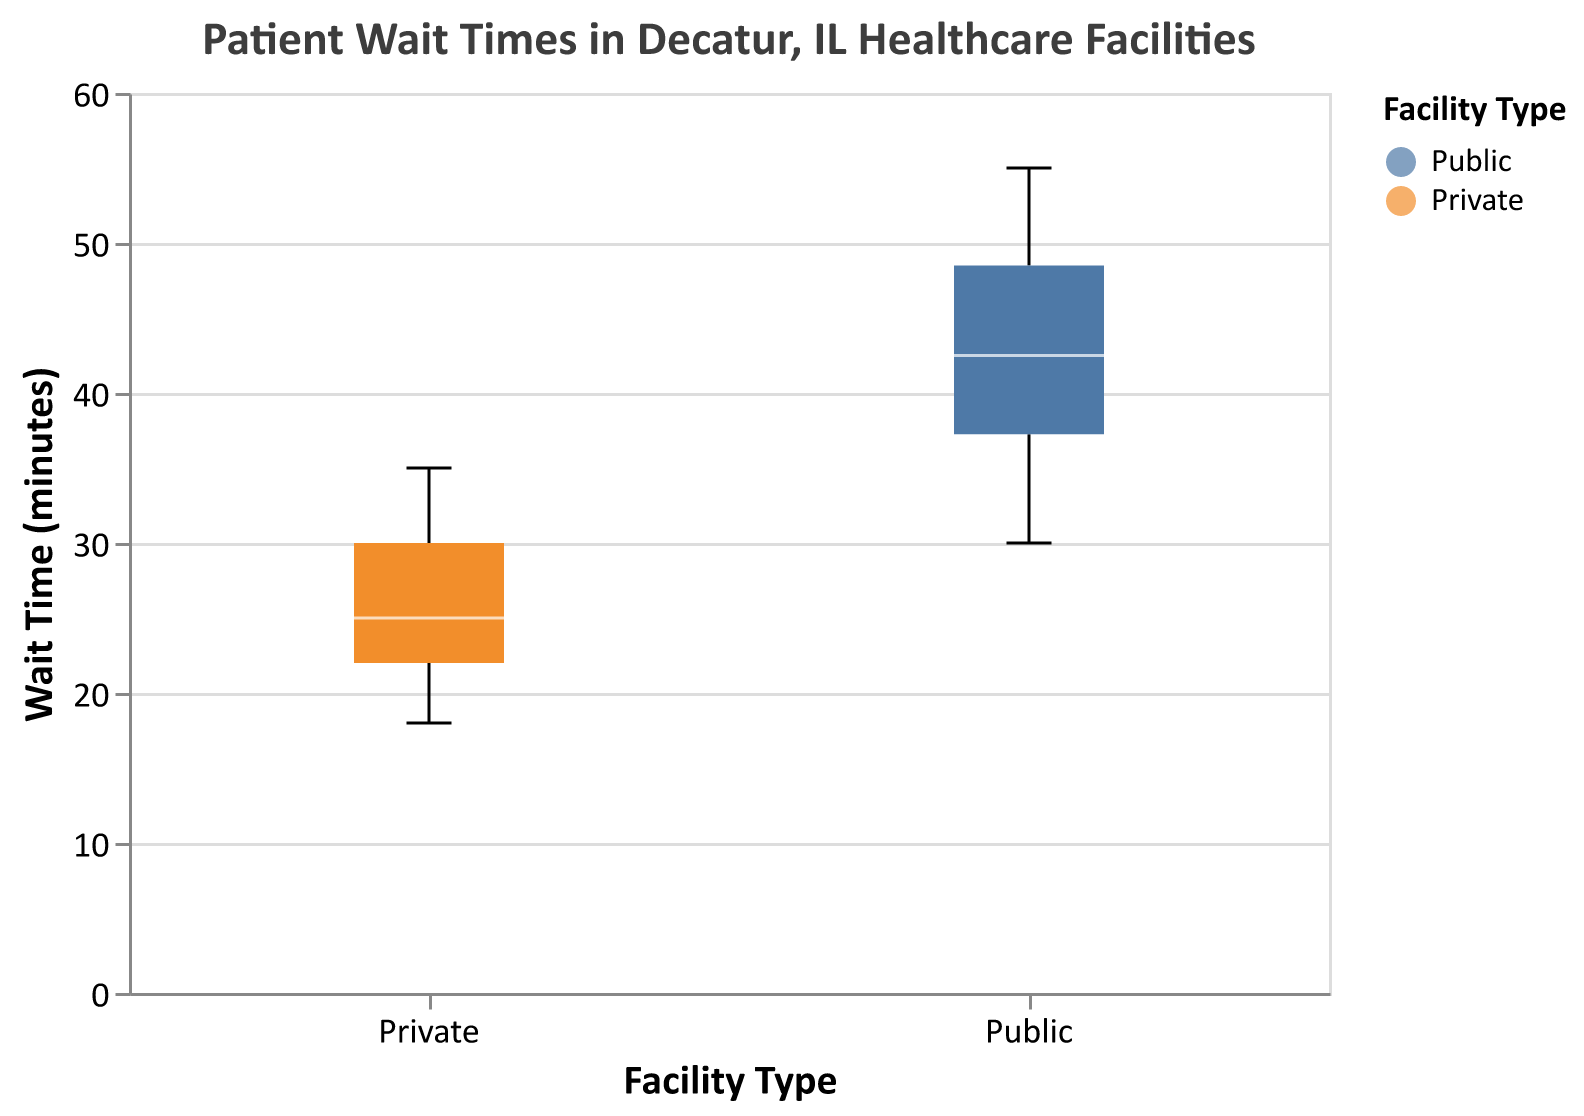what is the title of the figure? The title is usually displayed at the top of the figure. From the provided data, we can see that the title is "Patient Wait Times in Decatur, IL Healthcare Facilities."
Answer: Patient Wait Times in Decatur, IL Healthcare Facilities Which facility type has the higher median wait time? The median wait time for each facility type is indicated by a white line within each box. By comparing the two groups, we can see that the median wait time for Public facilities is higher than that for Private facilities.
Answer: Public What is the range of wait times for Public facilities? The range of wait times is the difference between the maximum and minimum values within a group. According to the box plot, the minimum wait time for Public facilities is 30 minutes and the maximum wait time is around 55 minutes. The range is 55 - 30.
Answer: 25 minutes What is the average wait time for Private facilities? To find the average, sum all wait times for Private facilities and divide by the number of points: (25 + 20 + 35 + 30 + 25 + 28 + 22 + 18 + 32) / 9. The sum is 235 minutes, and the average is 235/9.
Answer: 26.11 minutes Are there any outliers in the wait times? Outliers in a box plot are usually indicated by individual points that fall outside the "whiskers" of the box plot. By examining the figure, one can see if there are any points marked as outliers. In this case, there are no marked outliers.
Answer: No Which facility type has a greater spread in wait times? The spread is indicated by the length of the box and whiskers. By comparing the two, the Public facilities have a greater spread from 30 to 55 minutes, while Private facilities have a tighter spread.
Answer: Public How many Private facilities report wait times above the median of Public facilities? First, identify the median wait time of Public facilities, which appears to be around 40 minutes. Counting the points in the Private group above 40 minutes, there is only one wait time (35 minutes).
Answer: One What is the interquartile range (IQR) for Private facilities? The IQR is the difference between the third quartile (Q3) and the first quartile (Q1). From the plot, estimate the boundaries of the box for Private facilities. Q3 is around 30 minutes and Q1 is around 22 minutes. The IQR is 30 - 22.
Answer: 8 minutes What can you conclude about patient wait times between Public and Private facilities based on the figure? Comparing both medians and ranges, Public facilities have higher and more varied (wider spread) wait times than Private facilities, which indicates potentially longer and less predictable waits in Public facilities.
Answer: Public facilities have longer and less predictable wait times 